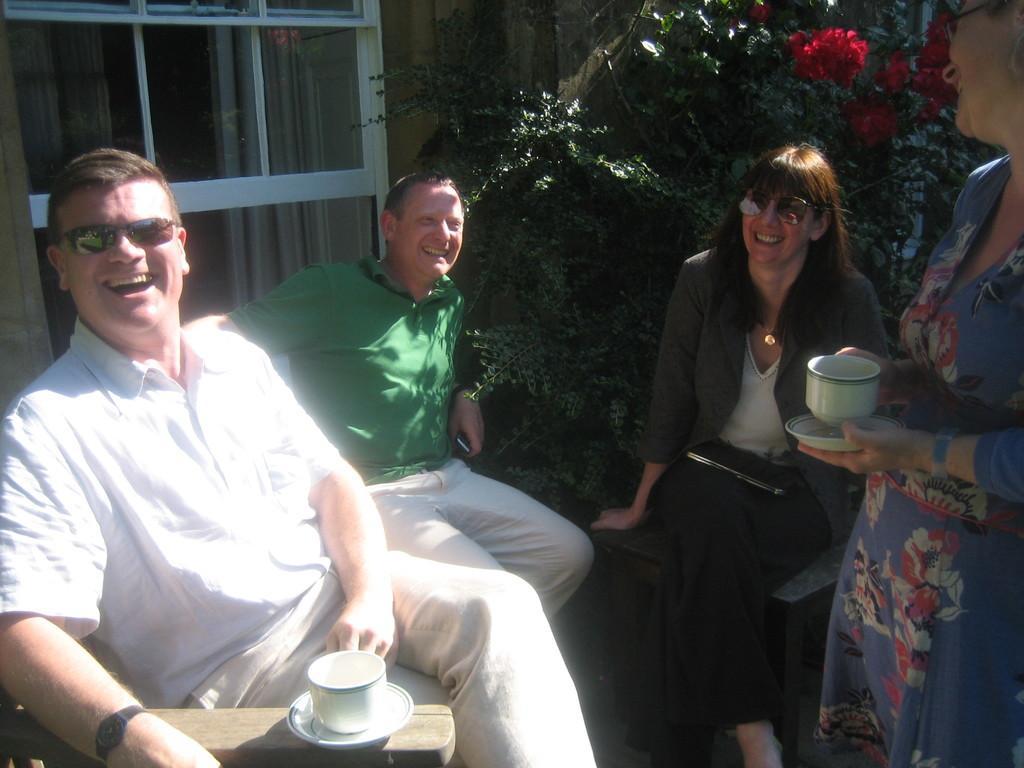Describe this image in one or two sentences. In this image I can see three persons are sitting on the chairs and one person is standing on the floor. In the background I can see plants, door and a curtain. This image is taken in a lawn during a day. 